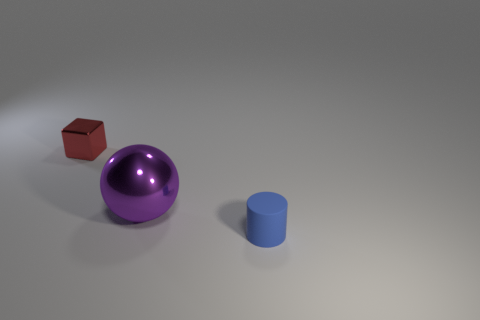Add 1 tiny red shiny blocks. How many objects exist? 4 Subtract all cylinders. How many objects are left? 2 Add 1 small cylinders. How many small cylinders exist? 2 Subtract 0 green balls. How many objects are left? 3 Subtract all big purple shiny things. Subtract all blue objects. How many objects are left? 1 Add 1 blue things. How many blue things are left? 2 